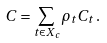<formula> <loc_0><loc_0><loc_500><loc_500>C = \sum _ { t \in X _ { c } } \rho _ { t } C _ { t } \, .</formula> 